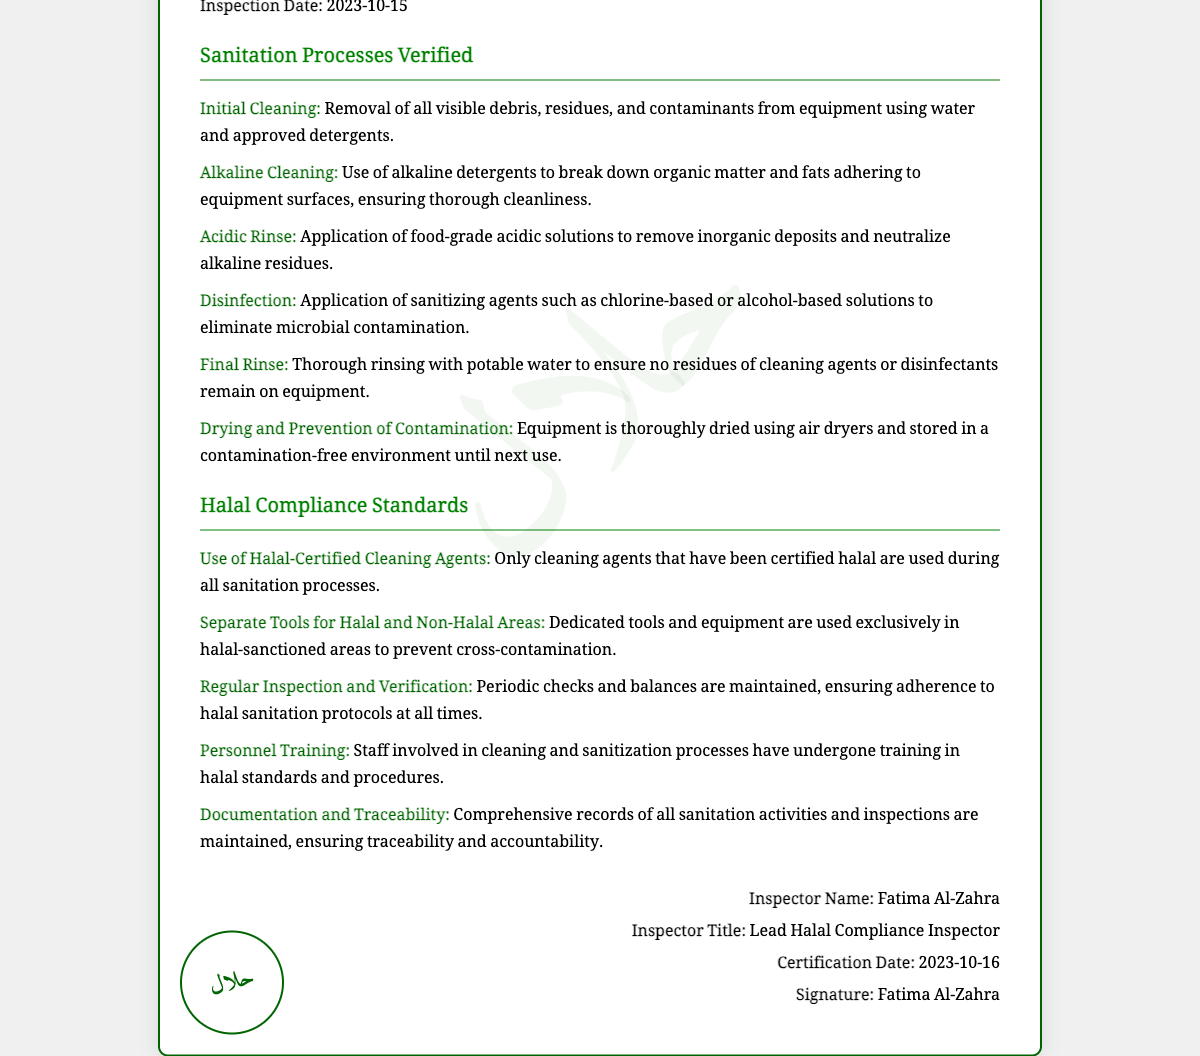What is the certification number? The certification number is specified in the document under issued details as HFSIA-2023-001.
Answer: HFSIA-2023-001 What is the name of the facility? The facility name is listed in the document as ABC Food Processing Plant.
Answer: ABC Food Processing Plant On what date was the inspection conducted? The inspection date is mentioned in the document as 2023-10-15.
Answer: 2023-10-15 What is the name of the lead halal compliance inspector? The name of the inspector is provided in the signature section of the document as Fatima Al-Zahra.
Answer: Fatima Al-Zahra What type of cleaning agents are used? The document specifies that halal-certified cleaning agents are used during sanitation processes.
Answer: Halal-Certified Cleaning Agents How many sanitation processes are listed in the document? The document includes a total of six sanitation processes that are verified.
Answer: Six What is the purpose of the acidic rinse process? The acidic rinse process is to remove inorganic deposits and neutralize alkaline residues as per sanitation standards.
Answer: Remove inorganic deposits What does the separate tools standard ensure? This standard ensures that dedicated tools and equipment are used to prevent cross-contamination.
Answer: Prevent cross-contamination When was the certification date? The certification date is found at the bottom of the document, specified as 2023-10-16.
Answer: 2023-10-16 